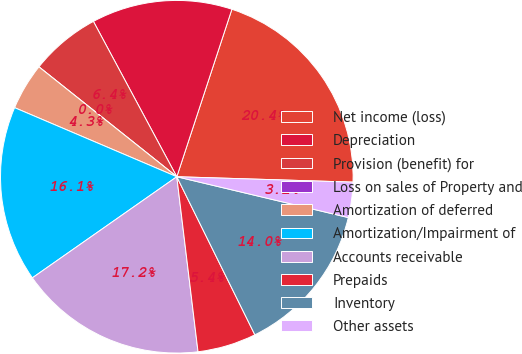<chart> <loc_0><loc_0><loc_500><loc_500><pie_chart><fcel>Net income (loss)<fcel>Depreciation<fcel>Provision (benefit) for<fcel>Loss on sales of Property and<fcel>Amortization of deferred<fcel>Amortization/Impairment of<fcel>Accounts receivable<fcel>Prepaids<fcel>Inventory<fcel>Other assets<nl><fcel>20.43%<fcel>12.9%<fcel>6.45%<fcel>0.0%<fcel>4.3%<fcel>16.13%<fcel>17.2%<fcel>5.38%<fcel>13.98%<fcel>3.23%<nl></chart> 